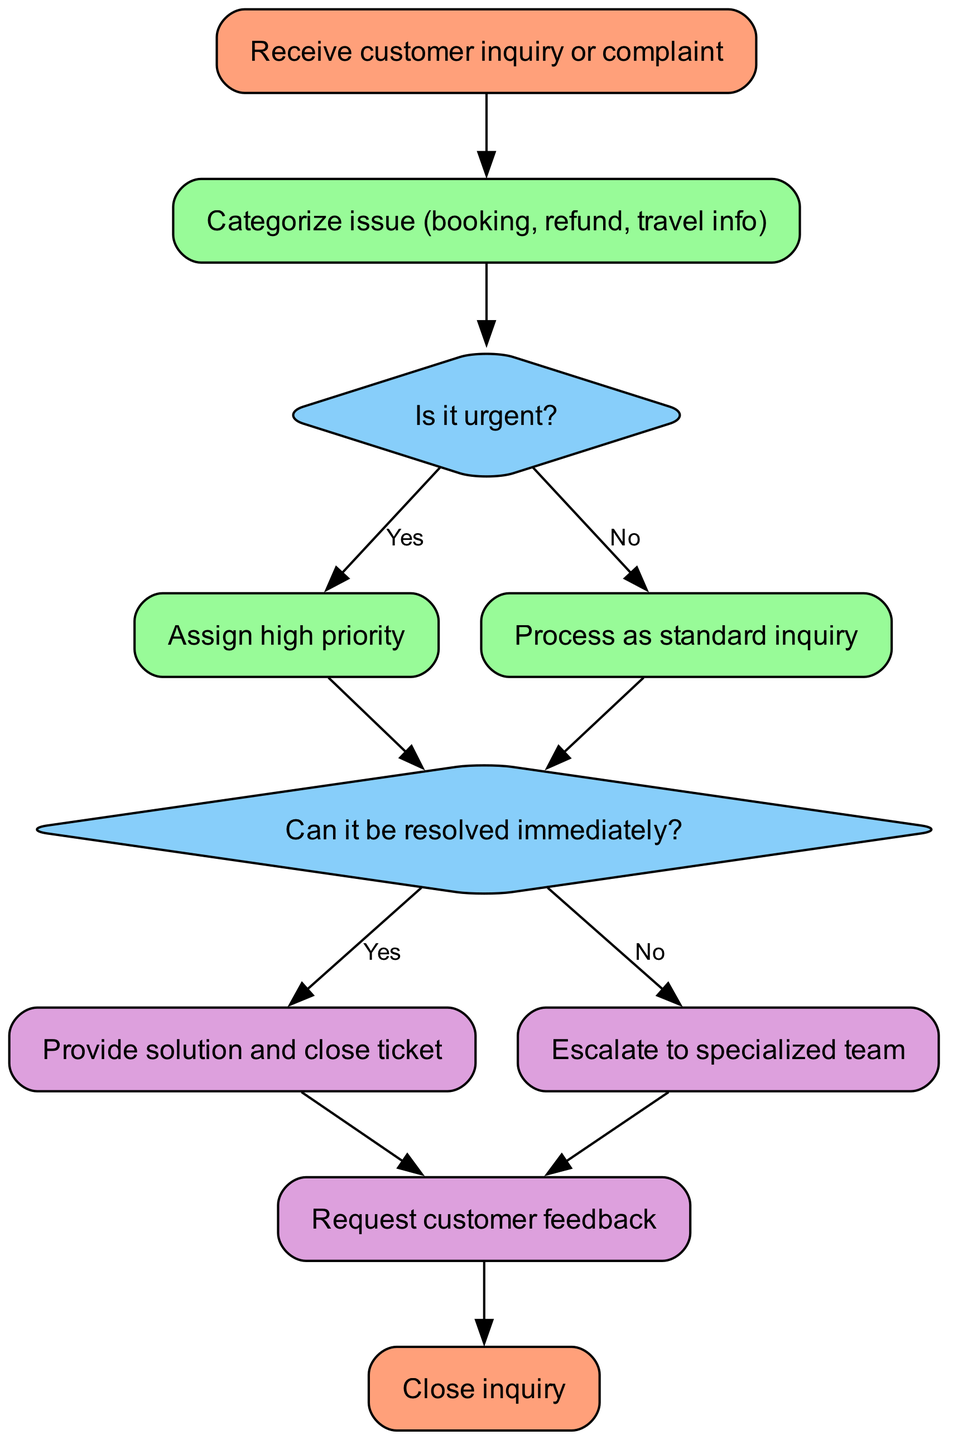What is the first step in the workflow? The diagram starts with the node labeled "Receive customer inquiry or complaint," which clearly states the initial action in the process.
Answer: Receive customer inquiry or complaint How many nodes are present in the diagram? By counting each unique node identified, we determine that there are a total of 10 nodes in the workflow diagram.
Answer: 10 What decision follows after categorizing the issue? After categorizing the issue, the next decision point is to determine if the issue is urgent, as indicated by the directed edge leading to the "Is it urgent?" node.
Answer: Is it urgent? What happens if the issue is resolved immediately? If the issue can be resolved immediately, the flow proceeds to "Provide solution and close ticket," indicating that the inquiry will be dealt with right away.
Answer: Provide solution and close ticket What is the final step in the workflow process? The last node in the diagram is labeled "Close inquiry," which indicates the completion of the customer support workflow.
Answer: Close inquiry If the issue is not urgent, what is the next action taken? If the issue is not urgent, the workflow directs to process the inquiry as standard, indicating a different handling path for non-urgent matters.
Answer: Process as standard inquiry What action follows escalation to a specialized team? After escalating to a specialized team, the workflow continues to "Request customer feedback," showing that feedback is sought regardless of the complexity of the issue.
Answer: Request customer feedback If immediate resolution isn't possible, what is the next step? If the issue cannot be resolved immediately, the flow moves to escalate the matter to a specialized team, indicating a need for further assistance.
Answer: Escalate to specialized team 